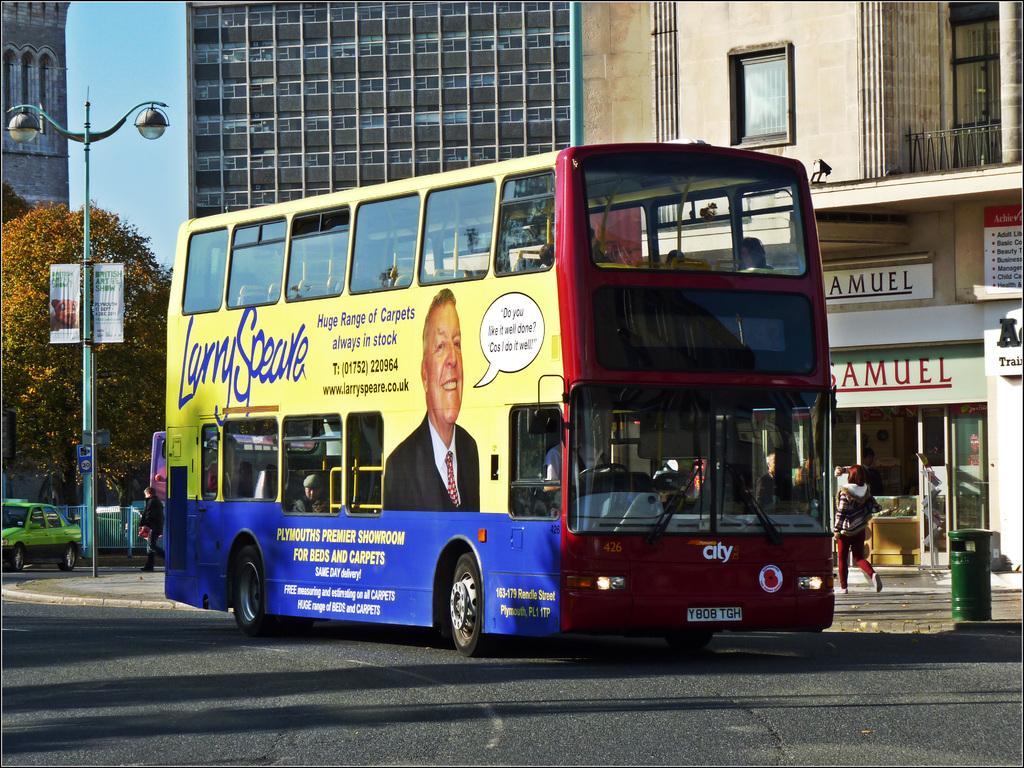In one or two sentences, can you explain what this image depicts? In this image there is a double Decker bus on the road. Behind the bus there are buildings. On the left side there is a pole to which there are two lights. There is a green colour car on the left side. There are stored under the buildings. On the right side there is a dustbin. There are few people walking on the footpath. 